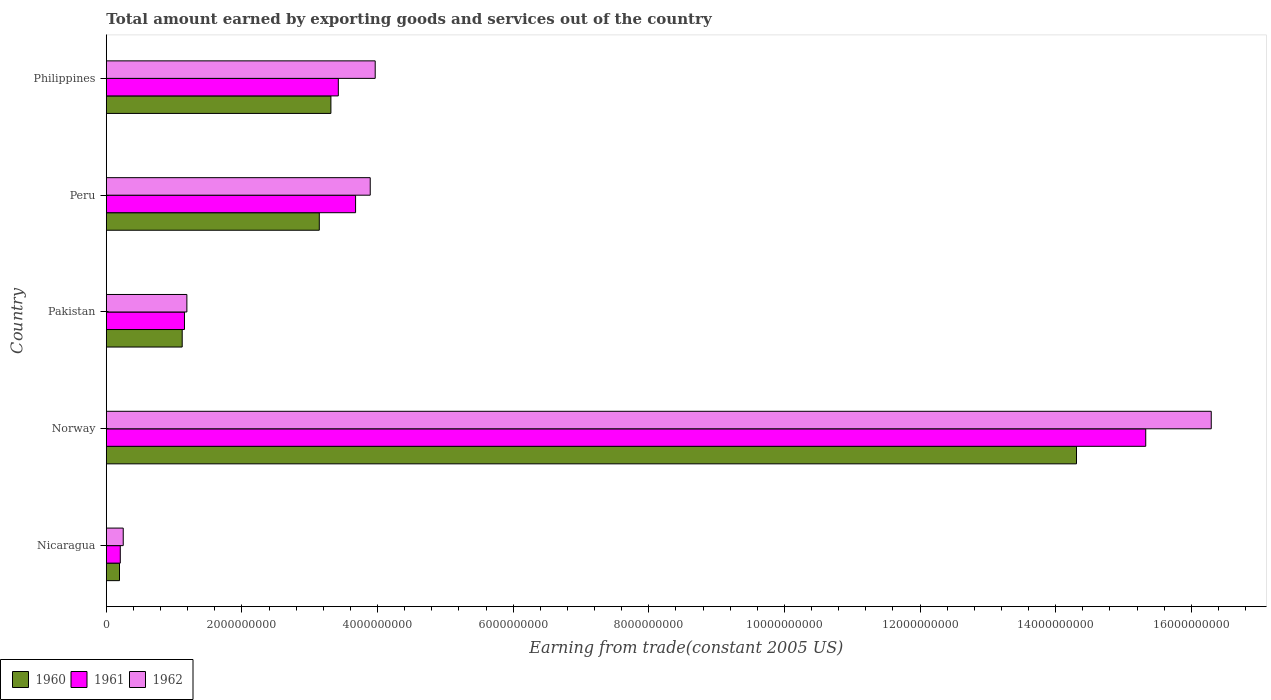Are the number of bars per tick equal to the number of legend labels?
Your answer should be very brief. Yes. Are the number of bars on each tick of the Y-axis equal?
Make the answer very short. Yes. How many bars are there on the 5th tick from the top?
Your answer should be very brief. 3. How many bars are there on the 2nd tick from the bottom?
Your answer should be compact. 3. What is the label of the 5th group of bars from the top?
Your answer should be compact. Nicaragua. In how many cases, is the number of bars for a given country not equal to the number of legend labels?
Give a very brief answer. 0. What is the total amount earned by exporting goods and services in 1960 in Norway?
Your answer should be compact. 1.43e+1. Across all countries, what is the maximum total amount earned by exporting goods and services in 1962?
Offer a very short reply. 1.63e+1. Across all countries, what is the minimum total amount earned by exporting goods and services in 1961?
Provide a succinct answer. 2.06e+08. In which country was the total amount earned by exporting goods and services in 1960 maximum?
Ensure brevity in your answer.  Norway. In which country was the total amount earned by exporting goods and services in 1960 minimum?
Offer a very short reply. Nicaragua. What is the total total amount earned by exporting goods and services in 1961 in the graph?
Your answer should be very brief. 2.38e+1. What is the difference between the total amount earned by exporting goods and services in 1962 in Nicaragua and that in Philippines?
Your answer should be compact. -3.72e+09. What is the difference between the total amount earned by exporting goods and services in 1960 in Peru and the total amount earned by exporting goods and services in 1962 in Philippines?
Make the answer very short. -8.24e+08. What is the average total amount earned by exporting goods and services in 1961 per country?
Offer a very short reply. 4.76e+09. What is the difference between the total amount earned by exporting goods and services in 1961 and total amount earned by exporting goods and services in 1962 in Philippines?
Give a very brief answer. -5.44e+08. What is the ratio of the total amount earned by exporting goods and services in 1962 in Nicaragua to that in Pakistan?
Your answer should be compact. 0.21. Is the difference between the total amount earned by exporting goods and services in 1961 in Nicaragua and Norway greater than the difference between the total amount earned by exporting goods and services in 1962 in Nicaragua and Norway?
Give a very brief answer. Yes. What is the difference between the highest and the second highest total amount earned by exporting goods and services in 1962?
Your response must be concise. 1.23e+1. What is the difference between the highest and the lowest total amount earned by exporting goods and services in 1961?
Your answer should be very brief. 1.51e+1. In how many countries, is the total amount earned by exporting goods and services in 1960 greater than the average total amount earned by exporting goods and services in 1960 taken over all countries?
Keep it short and to the point. 1. Is the sum of the total amount earned by exporting goods and services in 1961 in Peru and Philippines greater than the maximum total amount earned by exporting goods and services in 1960 across all countries?
Provide a succinct answer. No. What is the difference between two consecutive major ticks on the X-axis?
Your answer should be compact. 2.00e+09. Does the graph contain any zero values?
Your response must be concise. No. Where does the legend appear in the graph?
Keep it short and to the point. Bottom left. How many legend labels are there?
Give a very brief answer. 3. How are the legend labels stacked?
Keep it short and to the point. Horizontal. What is the title of the graph?
Provide a succinct answer. Total amount earned by exporting goods and services out of the country. Does "1981" appear as one of the legend labels in the graph?
Keep it short and to the point. No. What is the label or title of the X-axis?
Provide a short and direct response. Earning from trade(constant 2005 US). What is the label or title of the Y-axis?
Offer a terse response. Country. What is the Earning from trade(constant 2005 US) of 1960 in Nicaragua?
Give a very brief answer. 1.94e+08. What is the Earning from trade(constant 2005 US) of 1961 in Nicaragua?
Offer a terse response. 2.06e+08. What is the Earning from trade(constant 2005 US) of 1962 in Nicaragua?
Ensure brevity in your answer.  2.49e+08. What is the Earning from trade(constant 2005 US) in 1960 in Norway?
Provide a succinct answer. 1.43e+1. What is the Earning from trade(constant 2005 US) in 1961 in Norway?
Provide a short and direct response. 1.53e+1. What is the Earning from trade(constant 2005 US) in 1962 in Norway?
Keep it short and to the point. 1.63e+1. What is the Earning from trade(constant 2005 US) in 1960 in Pakistan?
Keep it short and to the point. 1.12e+09. What is the Earning from trade(constant 2005 US) in 1961 in Pakistan?
Provide a succinct answer. 1.15e+09. What is the Earning from trade(constant 2005 US) in 1962 in Pakistan?
Ensure brevity in your answer.  1.19e+09. What is the Earning from trade(constant 2005 US) of 1960 in Peru?
Ensure brevity in your answer.  3.14e+09. What is the Earning from trade(constant 2005 US) in 1961 in Peru?
Offer a terse response. 3.68e+09. What is the Earning from trade(constant 2005 US) in 1962 in Peru?
Give a very brief answer. 3.89e+09. What is the Earning from trade(constant 2005 US) of 1960 in Philippines?
Offer a terse response. 3.31e+09. What is the Earning from trade(constant 2005 US) of 1961 in Philippines?
Make the answer very short. 3.42e+09. What is the Earning from trade(constant 2005 US) of 1962 in Philippines?
Offer a very short reply. 3.97e+09. Across all countries, what is the maximum Earning from trade(constant 2005 US) in 1960?
Provide a short and direct response. 1.43e+1. Across all countries, what is the maximum Earning from trade(constant 2005 US) in 1961?
Give a very brief answer. 1.53e+1. Across all countries, what is the maximum Earning from trade(constant 2005 US) of 1962?
Your response must be concise. 1.63e+1. Across all countries, what is the minimum Earning from trade(constant 2005 US) in 1960?
Give a very brief answer. 1.94e+08. Across all countries, what is the minimum Earning from trade(constant 2005 US) in 1961?
Ensure brevity in your answer.  2.06e+08. Across all countries, what is the minimum Earning from trade(constant 2005 US) in 1962?
Keep it short and to the point. 2.49e+08. What is the total Earning from trade(constant 2005 US) in 1960 in the graph?
Your response must be concise. 2.21e+1. What is the total Earning from trade(constant 2005 US) of 1961 in the graph?
Ensure brevity in your answer.  2.38e+1. What is the total Earning from trade(constant 2005 US) in 1962 in the graph?
Your answer should be very brief. 2.56e+1. What is the difference between the Earning from trade(constant 2005 US) in 1960 in Nicaragua and that in Norway?
Give a very brief answer. -1.41e+1. What is the difference between the Earning from trade(constant 2005 US) of 1961 in Nicaragua and that in Norway?
Keep it short and to the point. -1.51e+1. What is the difference between the Earning from trade(constant 2005 US) of 1962 in Nicaragua and that in Norway?
Offer a very short reply. -1.60e+1. What is the difference between the Earning from trade(constant 2005 US) of 1960 in Nicaragua and that in Pakistan?
Provide a succinct answer. -9.25e+08. What is the difference between the Earning from trade(constant 2005 US) of 1961 in Nicaragua and that in Pakistan?
Ensure brevity in your answer.  -9.46e+08. What is the difference between the Earning from trade(constant 2005 US) in 1962 in Nicaragua and that in Pakistan?
Your response must be concise. -9.38e+08. What is the difference between the Earning from trade(constant 2005 US) of 1960 in Nicaragua and that in Peru?
Give a very brief answer. -2.95e+09. What is the difference between the Earning from trade(constant 2005 US) of 1961 in Nicaragua and that in Peru?
Offer a very short reply. -3.47e+09. What is the difference between the Earning from trade(constant 2005 US) in 1962 in Nicaragua and that in Peru?
Ensure brevity in your answer.  -3.64e+09. What is the difference between the Earning from trade(constant 2005 US) in 1960 in Nicaragua and that in Philippines?
Give a very brief answer. -3.12e+09. What is the difference between the Earning from trade(constant 2005 US) in 1961 in Nicaragua and that in Philippines?
Give a very brief answer. -3.22e+09. What is the difference between the Earning from trade(constant 2005 US) of 1962 in Nicaragua and that in Philippines?
Your answer should be compact. -3.72e+09. What is the difference between the Earning from trade(constant 2005 US) in 1960 in Norway and that in Pakistan?
Offer a terse response. 1.32e+1. What is the difference between the Earning from trade(constant 2005 US) in 1961 in Norway and that in Pakistan?
Provide a succinct answer. 1.42e+1. What is the difference between the Earning from trade(constant 2005 US) of 1962 in Norway and that in Pakistan?
Offer a very short reply. 1.51e+1. What is the difference between the Earning from trade(constant 2005 US) of 1960 in Norway and that in Peru?
Provide a short and direct response. 1.12e+1. What is the difference between the Earning from trade(constant 2005 US) of 1961 in Norway and that in Peru?
Make the answer very short. 1.17e+1. What is the difference between the Earning from trade(constant 2005 US) in 1962 in Norway and that in Peru?
Offer a very short reply. 1.24e+1. What is the difference between the Earning from trade(constant 2005 US) of 1960 in Norway and that in Philippines?
Ensure brevity in your answer.  1.10e+1. What is the difference between the Earning from trade(constant 2005 US) in 1961 in Norway and that in Philippines?
Provide a succinct answer. 1.19e+1. What is the difference between the Earning from trade(constant 2005 US) of 1962 in Norway and that in Philippines?
Your response must be concise. 1.23e+1. What is the difference between the Earning from trade(constant 2005 US) in 1960 in Pakistan and that in Peru?
Provide a short and direct response. -2.02e+09. What is the difference between the Earning from trade(constant 2005 US) in 1961 in Pakistan and that in Peru?
Provide a succinct answer. -2.52e+09. What is the difference between the Earning from trade(constant 2005 US) in 1962 in Pakistan and that in Peru?
Make the answer very short. -2.70e+09. What is the difference between the Earning from trade(constant 2005 US) in 1960 in Pakistan and that in Philippines?
Offer a very short reply. -2.19e+09. What is the difference between the Earning from trade(constant 2005 US) of 1961 in Pakistan and that in Philippines?
Your response must be concise. -2.27e+09. What is the difference between the Earning from trade(constant 2005 US) of 1962 in Pakistan and that in Philippines?
Make the answer very short. -2.78e+09. What is the difference between the Earning from trade(constant 2005 US) in 1960 in Peru and that in Philippines?
Your answer should be very brief. -1.71e+08. What is the difference between the Earning from trade(constant 2005 US) of 1961 in Peru and that in Philippines?
Your answer should be compact. 2.54e+08. What is the difference between the Earning from trade(constant 2005 US) of 1962 in Peru and that in Philippines?
Make the answer very short. -7.32e+07. What is the difference between the Earning from trade(constant 2005 US) in 1960 in Nicaragua and the Earning from trade(constant 2005 US) in 1961 in Norway?
Offer a very short reply. -1.51e+1. What is the difference between the Earning from trade(constant 2005 US) of 1960 in Nicaragua and the Earning from trade(constant 2005 US) of 1962 in Norway?
Offer a very short reply. -1.61e+1. What is the difference between the Earning from trade(constant 2005 US) of 1961 in Nicaragua and the Earning from trade(constant 2005 US) of 1962 in Norway?
Offer a very short reply. -1.61e+1. What is the difference between the Earning from trade(constant 2005 US) of 1960 in Nicaragua and the Earning from trade(constant 2005 US) of 1961 in Pakistan?
Provide a succinct answer. -9.58e+08. What is the difference between the Earning from trade(constant 2005 US) in 1960 in Nicaragua and the Earning from trade(constant 2005 US) in 1962 in Pakistan?
Give a very brief answer. -9.94e+08. What is the difference between the Earning from trade(constant 2005 US) in 1961 in Nicaragua and the Earning from trade(constant 2005 US) in 1962 in Pakistan?
Ensure brevity in your answer.  -9.82e+08. What is the difference between the Earning from trade(constant 2005 US) in 1960 in Nicaragua and the Earning from trade(constant 2005 US) in 1961 in Peru?
Ensure brevity in your answer.  -3.48e+09. What is the difference between the Earning from trade(constant 2005 US) in 1960 in Nicaragua and the Earning from trade(constant 2005 US) in 1962 in Peru?
Offer a terse response. -3.70e+09. What is the difference between the Earning from trade(constant 2005 US) in 1961 in Nicaragua and the Earning from trade(constant 2005 US) in 1962 in Peru?
Your answer should be very brief. -3.69e+09. What is the difference between the Earning from trade(constant 2005 US) in 1960 in Nicaragua and the Earning from trade(constant 2005 US) in 1961 in Philippines?
Make the answer very short. -3.23e+09. What is the difference between the Earning from trade(constant 2005 US) in 1960 in Nicaragua and the Earning from trade(constant 2005 US) in 1962 in Philippines?
Your response must be concise. -3.77e+09. What is the difference between the Earning from trade(constant 2005 US) of 1961 in Nicaragua and the Earning from trade(constant 2005 US) of 1962 in Philippines?
Offer a terse response. -3.76e+09. What is the difference between the Earning from trade(constant 2005 US) of 1960 in Norway and the Earning from trade(constant 2005 US) of 1961 in Pakistan?
Make the answer very short. 1.32e+1. What is the difference between the Earning from trade(constant 2005 US) in 1960 in Norway and the Earning from trade(constant 2005 US) in 1962 in Pakistan?
Your answer should be very brief. 1.31e+1. What is the difference between the Earning from trade(constant 2005 US) of 1961 in Norway and the Earning from trade(constant 2005 US) of 1962 in Pakistan?
Keep it short and to the point. 1.41e+1. What is the difference between the Earning from trade(constant 2005 US) of 1960 in Norway and the Earning from trade(constant 2005 US) of 1961 in Peru?
Your response must be concise. 1.06e+1. What is the difference between the Earning from trade(constant 2005 US) in 1960 in Norway and the Earning from trade(constant 2005 US) in 1962 in Peru?
Your answer should be compact. 1.04e+1. What is the difference between the Earning from trade(constant 2005 US) in 1961 in Norway and the Earning from trade(constant 2005 US) in 1962 in Peru?
Provide a succinct answer. 1.14e+1. What is the difference between the Earning from trade(constant 2005 US) of 1960 in Norway and the Earning from trade(constant 2005 US) of 1961 in Philippines?
Offer a terse response. 1.09e+1. What is the difference between the Earning from trade(constant 2005 US) of 1960 in Norway and the Earning from trade(constant 2005 US) of 1962 in Philippines?
Ensure brevity in your answer.  1.03e+1. What is the difference between the Earning from trade(constant 2005 US) of 1961 in Norway and the Earning from trade(constant 2005 US) of 1962 in Philippines?
Make the answer very short. 1.14e+1. What is the difference between the Earning from trade(constant 2005 US) of 1960 in Pakistan and the Earning from trade(constant 2005 US) of 1961 in Peru?
Provide a succinct answer. -2.56e+09. What is the difference between the Earning from trade(constant 2005 US) of 1960 in Pakistan and the Earning from trade(constant 2005 US) of 1962 in Peru?
Your response must be concise. -2.77e+09. What is the difference between the Earning from trade(constant 2005 US) in 1961 in Pakistan and the Earning from trade(constant 2005 US) in 1962 in Peru?
Provide a succinct answer. -2.74e+09. What is the difference between the Earning from trade(constant 2005 US) of 1960 in Pakistan and the Earning from trade(constant 2005 US) of 1961 in Philippines?
Your answer should be very brief. -2.30e+09. What is the difference between the Earning from trade(constant 2005 US) of 1960 in Pakistan and the Earning from trade(constant 2005 US) of 1962 in Philippines?
Provide a short and direct response. -2.85e+09. What is the difference between the Earning from trade(constant 2005 US) in 1961 in Pakistan and the Earning from trade(constant 2005 US) in 1962 in Philippines?
Provide a succinct answer. -2.81e+09. What is the difference between the Earning from trade(constant 2005 US) in 1960 in Peru and the Earning from trade(constant 2005 US) in 1961 in Philippines?
Offer a very short reply. -2.81e+08. What is the difference between the Earning from trade(constant 2005 US) of 1960 in Peru and the Earning from trade(constant 2005 US) of 1962 in Philippines?
Your answer should be compact. -8.24e+08. What is the difference between the Earning from trade(constant 2005 US) in 1961 in Peru and the Earning from trade(constant 2005 US) in 1962 in Philippines?
Provide a succinct answer. -2.89e+08. What is the average Earning from trade(constant 2005 US) of 1960 per country?
Your response must be concise. 4.41e+09. What is the average Earning from trade(constant 2005 US) of 1961 per country?
Your answer should be very brief. 4.76e+09. What is the average Earning from trade(constant 2005 US) in 1962 per country?
Keep it short and to the point. 5.12e+09. What is the difference between the Earning from trade(constant 2005 US) of 1960 and Earning from trade(constant 2005 US) of 1961 in Nicaragua?
Your answer should be compact. -1.16e+07. What is the difference between the Earning from trade(constant 2005 US) in 1960 and Earning from trade(constant 2005 US) in 1962 in Nicaragua?
Provide a succinct answer. -5.51e+07. What is the difference between the Earning from trade(constant 2005 US) of 1961 and Earning from trade(constant 2005 US) of 1962 in Nicaragua?
Provide a succinct answer. -4.35e+07. What is the difference between the Earning from trade(constant 2005 US) in 1960 and Earning from trade(constant 2005 US) in 1961 in Norway?
Your answer should be very brief. -1.02e+09. What is the difference between the Earning from trade(constant 2005 US) in 1960 and Earning from trade(constant 2005 US) in 1962 in Norway?
Offer a very short reply. -1.99e+09. What is the difference between the Earning from trade(constant 2005 US) in 1961 and Earning from trade(constant 2005 US) in 1962 in Norway?
Give a very brief answer. -9.66e+08. What is the difference between the Earning from trade(constant 2005 US) of 1960 and Earning from trade(constant 2005 US) of 1961 in Pakistan?
Make the answer very short. -3.35e+07. What is the difference between the Earning from trade(constant 2005 US) in 1960 and Earning from trade(constant 2005 US) in 1962 in Pakistan?
Make the answer very short. -6.89e+07. What is the difference between the Earning from trade(constant 2005 US) in 1961 and Earning from trade(constant 2005 US) in 1962 in Pakistan?
Your response must be concise. -3.54e+07. What is the difference between the Earning from trade(constant 2005 US) of 1960 and Earning from trade(constant 2005 US) of 1961 in Peru?
Give a very brief answer. -5.35e+08. What is the difference between the Earning from trade(constant 2005 US) in 1960 and Earning from trade(constant 2005 US) in 1962 in Peru?
Provide a short and direct response. -7.51e+08. What is the difference between the Earning from trade(constant 2005 US) of 1961 and Earning from trade(constant 2005 US) of 1962 in Peru?
Provide a short and direct response. -2.16e+08. What is the difference between the Earning from trade(constant 2005 US) in 1960 and Earning from trade(constant 2005 US) in 1961 in Philippines?
Your answer should be compact. -1.10e+08. What is the difference between the Earning from trade(constant 2005 US) of 1960 and Earning from trade(constant 2005 US) of 1962 in Philippines?
Ensure brevity in your answer.  -6.53e+08. What is the difference between the Earning from trade(constant 2005 US) of 1961 and Earning from trade(constant 2005 US) of 1962 in Philippines?
Offer a terse response. -5.44e+08. What is the ratio of the Earning from trade(constant 2005 US) in 1960 in Nicaragua to that in Norway?
Your answer should be very brief. 0.01. What is the ratio of the Earning from trade(constant 2005 US) in 1961 in Nicaragua to that in Norway?
Your answer should be compact. 0.01. What is the ratio of the Earning from trade(constant 2005 US) of 1962 in Nicaragua to that in Norway?
Provide a short and direct response. 0.02. What is the ratio of the Earning from trade(constant 2005 US) in 1960 in Nicaragua to that in Pakistan?
Offer a very short reply. 0.17. What is the ratio of the Earning from trade(constant 2005 US) in 1961 in Nicaragua to that in Pakistan?
Offer a very short reply. 0.18. What is the ratio of the Earning from trade(constant 2005 US) of 1962 in Nicaragua to that in Pakistan?
Your answer should be compact. 0.21. What is the ratio of the Earning from trade(constant 2005 US) of 1960 in Nicaragua to that in Peru?
Give a very brief answer. 0.06. What is the ratio of the Earning from trade(constant 2005 US) in 1961 in Nicaragua to that in Peru?
Offer a very short reply. 0.06. What is the ratio of the Earning from trade(constant 2005 US) of 1962 in Nicaragua to that in Peru?
Your answer should be compact. 0.06. What is the ratio of the Earning from trade(constant 2005 US) of 1960 in Nicaragua to that in Philippines?
Provide a succinct answer. 0.06. What is the ratio of the Earning from trade(constant 2005 US) in 1961 in Nicaragua to that in Philippines?
Your response must be concise. 0.06. What is the ratio of the Earning from trade(constant 2005 US) of 1962 in Nicaragua to that in Philippines?
Your answer should be very brief. 0.06. What is the ratio of the Earning from trade(constant 2005 US) in 1960 in Norway to that in Pakistan?
Your response must be concise. 12.79. What is the ratio of the Earning from trade(constant 2005 US) in 1961 in Norway to that in Pakistan?
Provide a short and direct response. 13.3. What is the ratio of the Earning from trade(constant 2005 US) of 1962 in Norway to that in Pakistan?
Your answer should be very brief. 13.72. What is the ratio of the Earning from trade(constant 2005 US) in 1960 in Norway to that in Peru?
Your response must be concise. 4.56. What is the ratio of the Earning from trade(constant 2005 US) of 1961 in Norway to that in Peru?
Offer a terse response. 4.17. What is the ratio of the Earning from trade(constant 2005 US) in 1962 in Norway to that in Peru?
Your answer should be very brief. 4.19. What is the ratio of the Earning from trade(constant 2005 US) of 1960 in Norway to that in Philippines?
Your answer should be very brief. 4.32. What is the ratio of the Earning from trade(constant 2005 US) in 1961 in Norway to that in Philippines?
Offer a very short reply. 4.48. What is the ratio of the Earning from trade(constant 2005 US) of 1962 in Norway to that in Philippines?
Your response must be concise. 4.11. What is the ratio of the Earning from trade(constant 2005 US) in 1960 in Pakistan to that in Peru?
Your answer should be very brief. 0.36. What is the ratio of the Earning from trade(constant 2005 US) in 1961 in Pakistan to that in Peru?
Your answer should be compact. 0.31. What is the ratio of the Earning from trade(constant 2005 US) of 1962 in Pakistan to that in Peru?
Your answer should be very brief. 0.31. What is the ratio of the Earning from trade(constant 2005 US) in 1960 in Pakistan to that in Philippines?
Your answer should be very brief. 0.34. What is the ratio of the Earning from trade(constant 2005 US) in 1961 in Pakistan to that in Philippines?
Your answer should be very brief. 0.34. What is the ratio of the Earning from trade(constant 2005 US) in 1962 in Pakistan to that in Philippines?
Ensure brevity in your answer.  0.3. What is the ratio of the Earning from trade(constant 2005 US) of 1960 in Peru to that in Philippines?
Keep it short and to the point. 0.95. What is the ratio of the Earning from trade(constant 2005 US) of 1961 in Peru to that in Philippines?
Offer a very short reply. 1.07. What is the ratio of the Earning from trade(constant 2005 US) of 1962 in Peru to that in Philippines?
Ensure brevity in your answer.  0.98. What is the difference between the highest and the second highest Earning from trade(constant 2005 US) of 1960?
Your answer should be very brief. 1.10e+1. What is the difference between the highest and the second highest Earning from trade(constant 2005 US) of 1961?
Make the answer very short. 1.17e+1. What is the difference between the highest and the second highest Earning from trade(constant 2005 US) in 1962?
Your answer should be compact. 1.23e+1. What is the difference between the highest and the lowest Earning from trade(constant 2005 US) in 1960?
Offer a terse response. 1.41e+1. What is the difference between the highest and the lowest Earning from trade(constant 2005 US) in 1961?
Offer a very short reply. 1.51e+1. What is the difference between the highest and the lowest Earning from trade(constant 2005 US) of 1962?
Keep it short and to the point. 1.60e+1. 